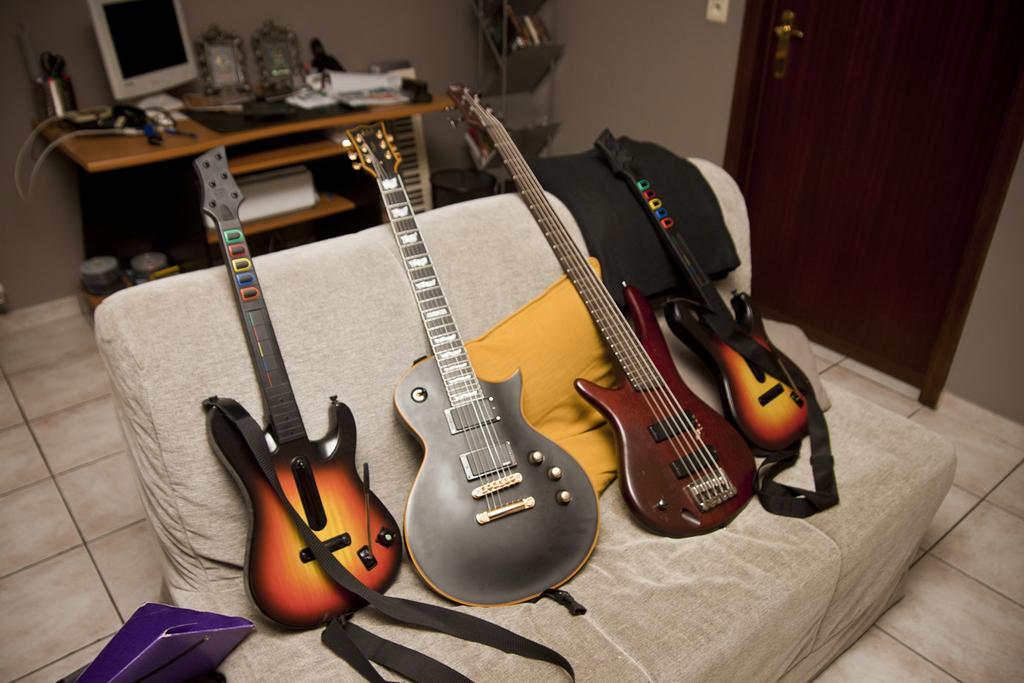Could you give a brief overview of what you see in this image? Here we can see four different guitars placed on a couch and behind them we can see a table with a system on it and there are books present on it and beside that we can see a door 